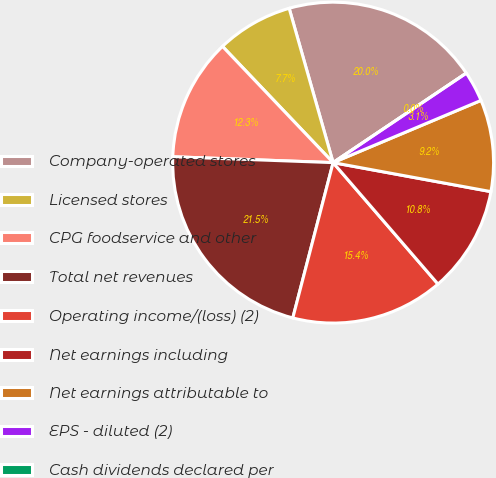Convert chart to OTSL. <chart><loc_0><loc_0><loc_500><loc_500><pie_chart><fcel>Company-operated stores<fcel>Licensed stores<fcel>CPG foodservice and other<fcel>Total net revenues<fcel>Operating income/(loss) (2)<fcel>Net earnings including<fcel>Net earnings attributable to<fcel>EPS - diluted (2)<fcel>Cash dividends declared per<nl><fcel>20.0%<fcel>7.69%<fcel>12.31%<fcel>21.54%<fcel>15.38%<fcel>10.77%<fcel>9.23%<fcel>3.08%<fcel>0.0%<nl></chart> 